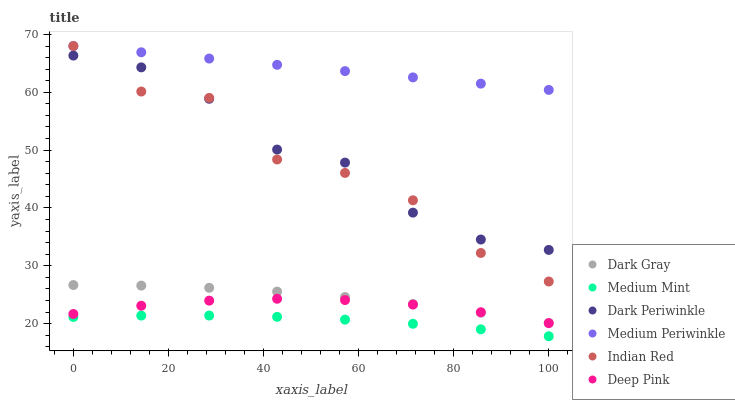Does Medium Mint have the minimum area under the curve?
Answer yes or no. Yes. Does Medium Periwinkle have the maximum area under the curve?
Answer yes or no. Yes. Does Deep Pink have the minimum area under the curve?
Answer yes or no. No. Does Deep Pink have the maximum area under the curve?
Answer yes or no. No. Is Medium Periwinkle the smoothest?
Answer yes or no. Yes. Is Indian Red the roughest?
Answer yes or no. Yes. Is Deep Pink the smoothest?
Answer yes or no. No. Is Deep Pink the roughest?
Answer yes or no. No. Does Medium Mint have the lowest value?
Answer yes or no. Yes. Does Deep Pink have the lowest value?
Answer yes or no. No. Does Indian Red have the highest value?
Answer yes or no. Yes. Does Deep Pink have the highest value?
Answer yes or no. No. Is Deep Pink less than Indian Red?
Answer yes or no. Yes. Is Medium Periwinkle greater than Dark Periwinkle?
Answer yes or no. Yes. Does Dark Periwinkle intersect Indian Red?
Answer yes or no. Yes. Is Dark Periwinkle less than Indian Red?
Answer yes or no. No. Is Dark Periwinkle greater than Indian Red?
Answer yes or no. No. Does Deep Pink intersect Indian Red?
Answer yes or no. No. 